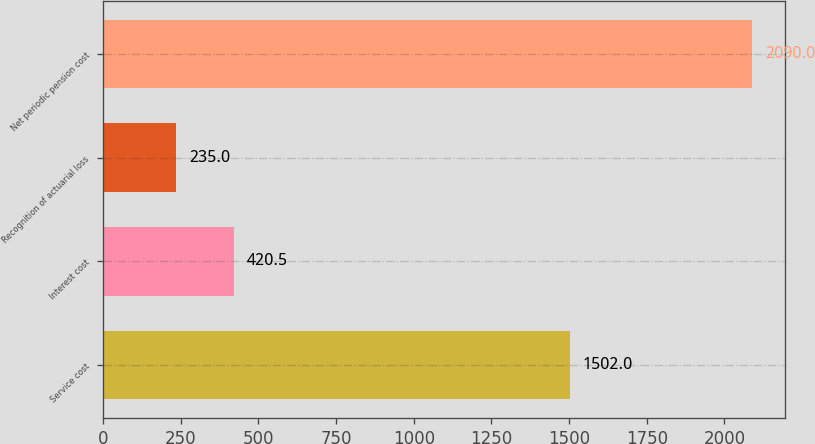Convert chart. <chart><loc_0><loc_0><loc_500><loc_500><bar_chart><fcel>Service cost<fcel>Interest cost<fcel>Recognition of actuarial loss<fcel>Net periodic pension cost<nl><fcel>1502<fcel>420.5<fcel>235<fcel>2090<nl></chart> 